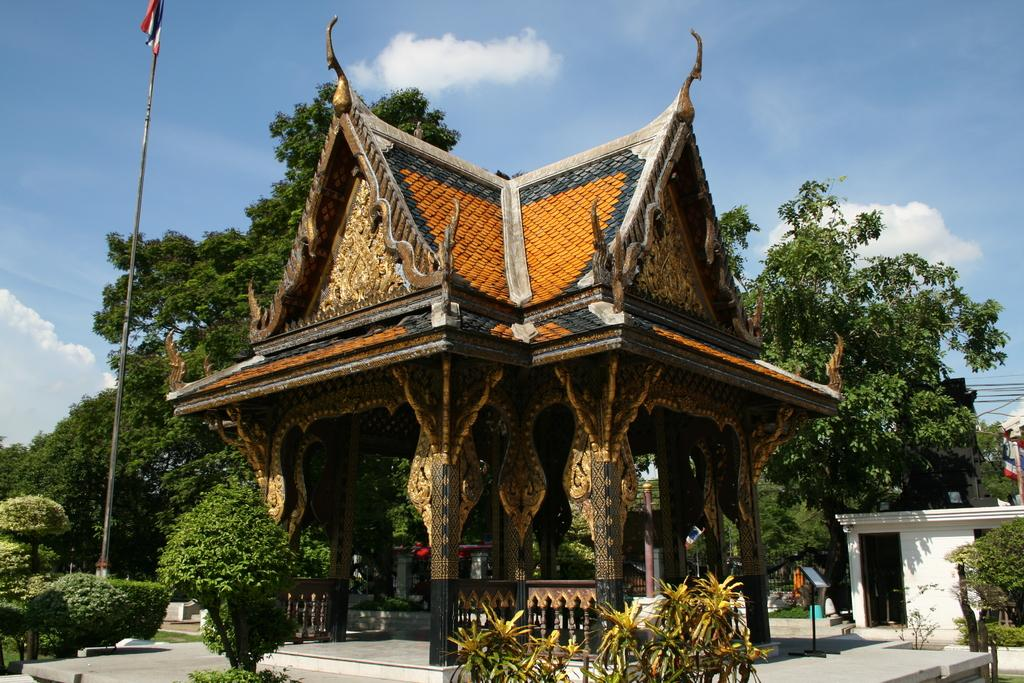What type of building is shown in the image? There is a museum in the image. What can be seen in the background of the image? There are trees and clouds in the sky in the background of the image. How many girls are playing with a bomb in the image? There are no girls or bombs present in the image. 